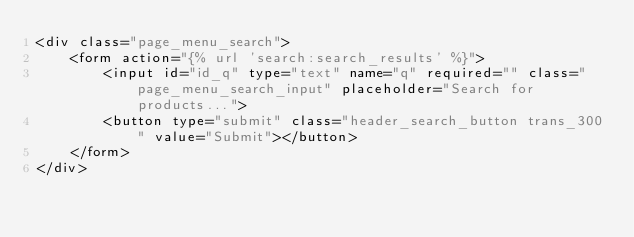<code> <loc_0><loc_0><loc_500><loc_500><_HTML_><div class="page_menu_search">
    <form action="{% url 'search:search_results' %}">
        <input id="id_q" type="text" name="q" required="" class="page_menu_search_input" placeholder="Search for products...">
        <button type="submit" class="header_search_button trans_300" value="Submit"></button>
    </form>
</div>

</code> 